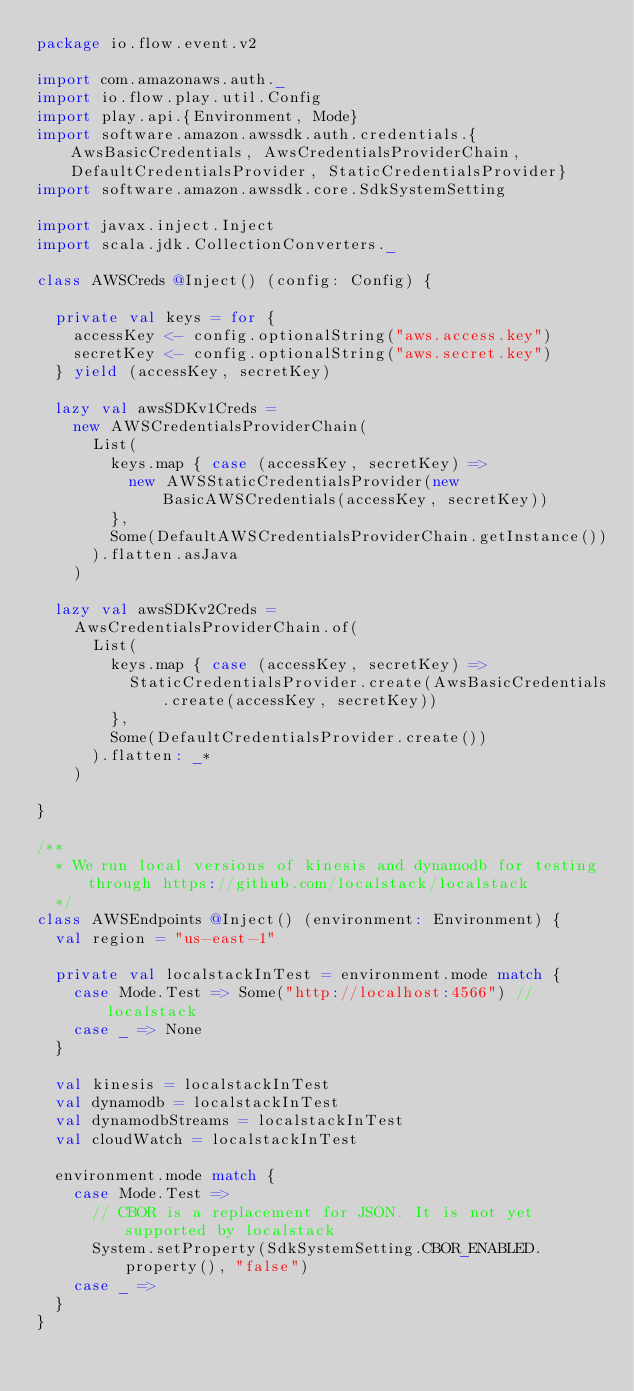Convert code to text. <code><loc_0><loc_0><loc_500><loc_500><_Scala_>package io.flow.event.v2

import com.amazonaws.auth._
import io.flow.play.util.Config
import play.api.{Environment, Mode}
import software.amazon.awssdk.auth.credentials.{AwsBasicCredentials, AwsCredentialsProviderChain, DefaultCredentialsProvider, StaticCredentialsProvider}
import software.amazon.awssdk.core.SdkSystemSetting

import javax.inject.Inject
import scala.jdk.CollectionConverters._

class AWSCreds @Inject() (config: Config) {

  private val keys = for {
    accessKey <- config.optionalString("aws.access.key")
    secretKey <- config.optionalString("aws.secret.key")
  } yield (accessKey, secretKey)

  lazy val awsSDKv1Creds =
    new AWSCredentialsProviderChain(
      List(
        keys.map { case (accessKey, secretKey) =>
          new AWSStaticCredentialsProvider(new BasicAWSCredentials(accessKey, secretKey))
        },
        Some(DefaultAWSCredentialsProviderChain.getInstance())
      ).flatten.asJava
    )

  lazy val awsSDKv2Creds =
    AwsCredentialsProviderChain.of(
      List(
        keys.map { case (accessKey, secretKey) =>
          StaticCredentialsProvider.create(AwsBasicCredentials.create(accessKey, secretKey))
        },
        Some(DefaultCredentialsProvider.create())
      ).flatten: _*
    )

}

/**
  * We run local versions of kinesis and dynamodb for testing through https://github.com/localstack/localstack
  */
class AWSEndpoints @Inject() (environment: Environment) {
  val region = "us-east-1"

  private val localstackInTest = environment.mode match {
    case Mode.Test => Some("http://localhost:4566") // localstack
    case _ => None
  }

  val kinesis = localstackInTest
  val dynamodb = localstackInTest
  val dynamodbStreams = localstackInTest
  val cloudWatch = localstackInTest

  environment.mode match {
    case Mode.Test =>
      // CBOR is a replacement for JSON. It is not yet supported by localstack
      System.setProperty(SdkSystemSetting.CBOR_ENABLED.property(), "false")
    case _ =>
  }
}
</code> 